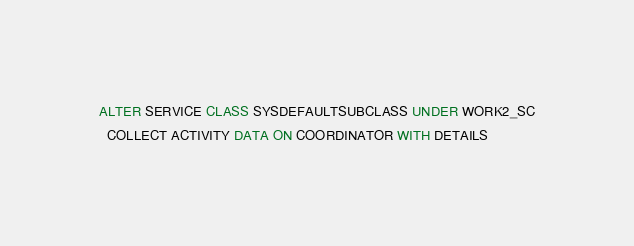Convert code to text. <code><loc_0><loc_0><loc_500><loc_500><_SQL_>ALTER SERVICE CLASS SYSDEFAULTSUBCLASS UNDER WORK2_SC
  COLLECT ACTIVITY DATA ON COORDINATOR WITH DETAILS</code> 